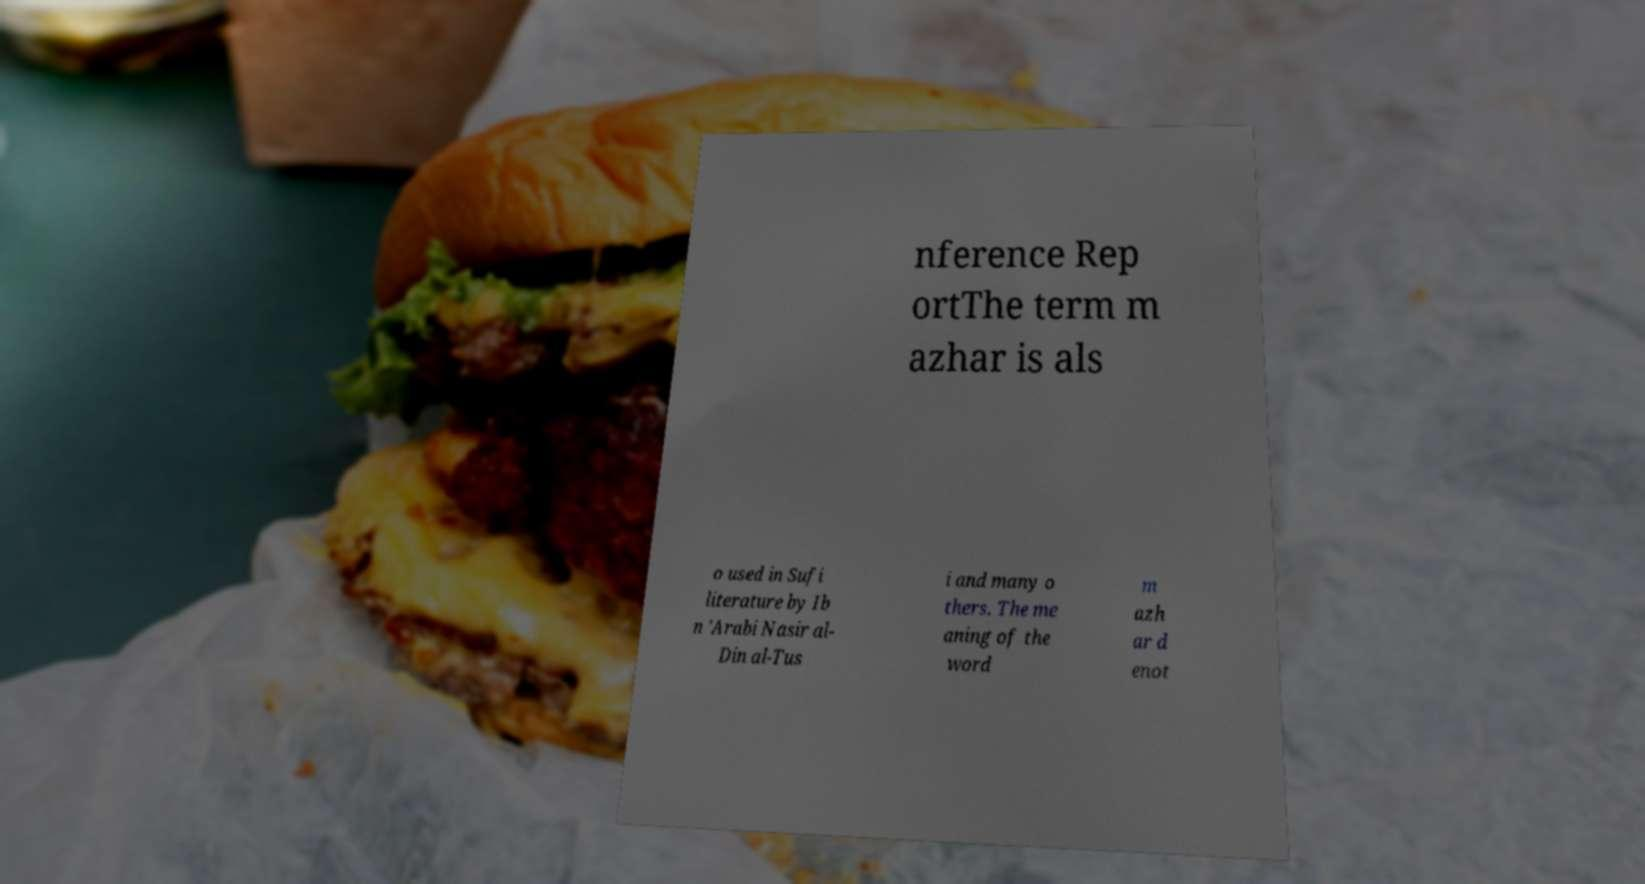Can you accurately transcribe the text from the provided image for me? nference Rep ortThe term m azhar is als o used in Sufi literature by Ib n 'Arabi Nasir al- Din al-Tus i and many o thers. The me aning of the word m azh ar d enot 